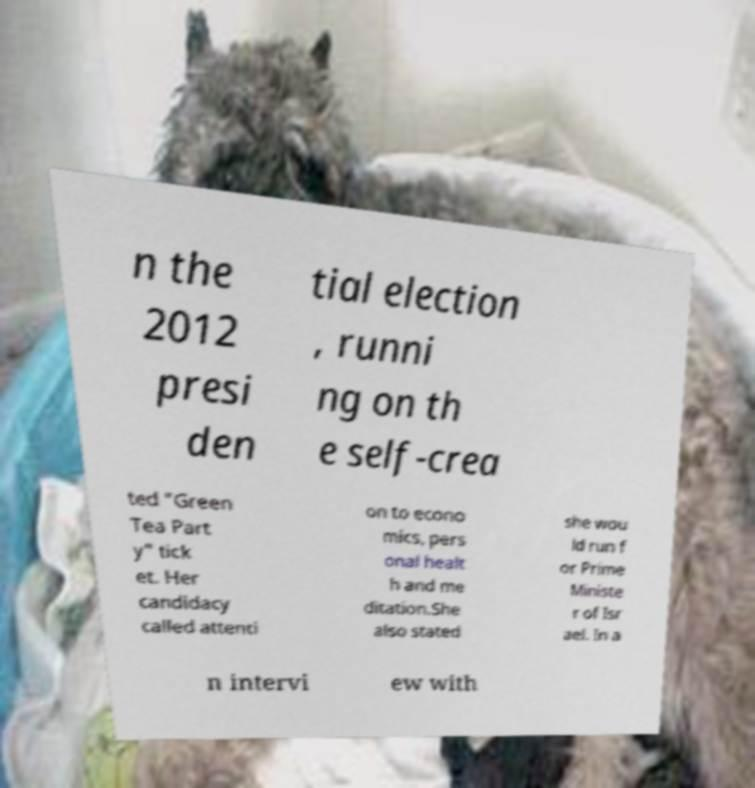Could you assist in decoding the text presented in this image and type it out clearly? n the 2012 presi den tial election , runni ng on th e self-crea ted "Green Tea Part y" tick et. Her candidacy called attenti on to econo mics, pers onal healt h and me ditation.She also stated she wou ld run f or Prime Ministe r of Isr ael. In a n intervi ew with 